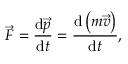Convert formula to latex. <formula><loc_0><loc_0><loc_500><loc_500>{ \vec { F } } = { \frac { d { \vec { p } } } { d t } } = { \frac { d \left ( m { \vec { v } } \right ) } { d t } } ,</formula> 